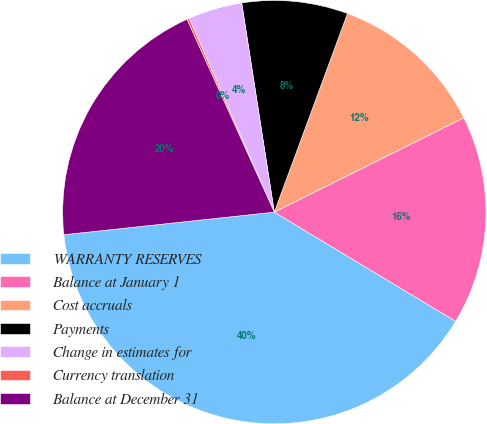Convert chart. <chart><loc_0><loc_0><loc_500><loc_500><pie_chart><fcel>WARRANTY RESERVES<fcel>Balance at January 1<fcel>Cost accruals<fcel>Payments<fcel>Change in estimates for<fcel>Currency translation<fcel>Balance at December 31<nl><fcel>39.67%<fcel>15.98%<fcel>12.03%<fcel>8.08%<fcel>4.13%<fcel>0.18%<fcel>19.93%<nl></chart> 